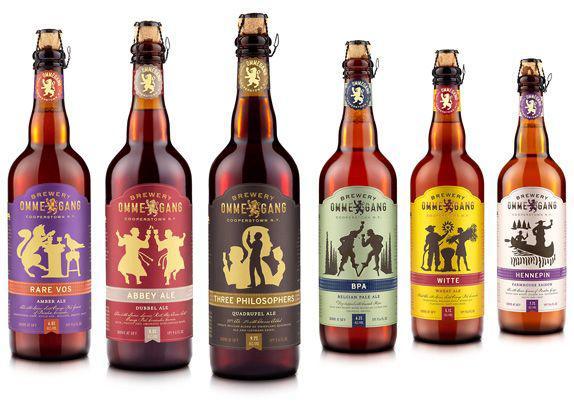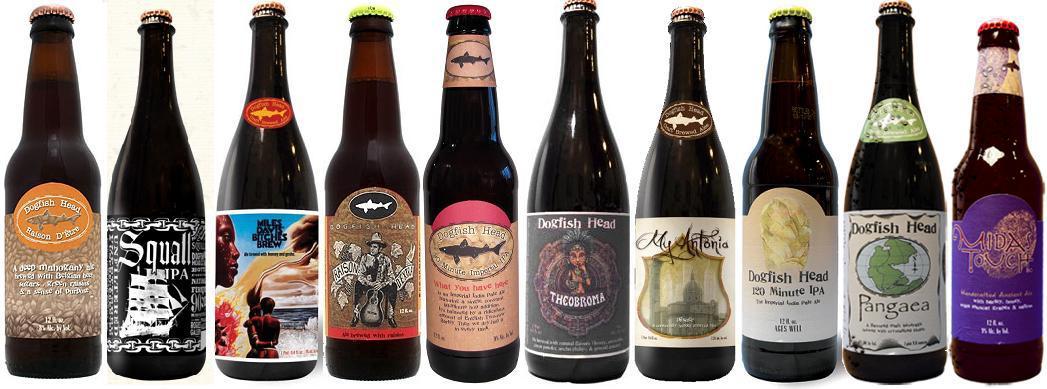The first image is the image on the left, the second image is the image on the right. For the images displayed, is the sentence "There is no more than 8 bottles." factually correct? Answer yes or no. No. The first image is the image on the left, the second image is the image on the right. For the images shown, is this caption "The bottles in the image on the left don't have lablels." true? Answer yes or no. No. 